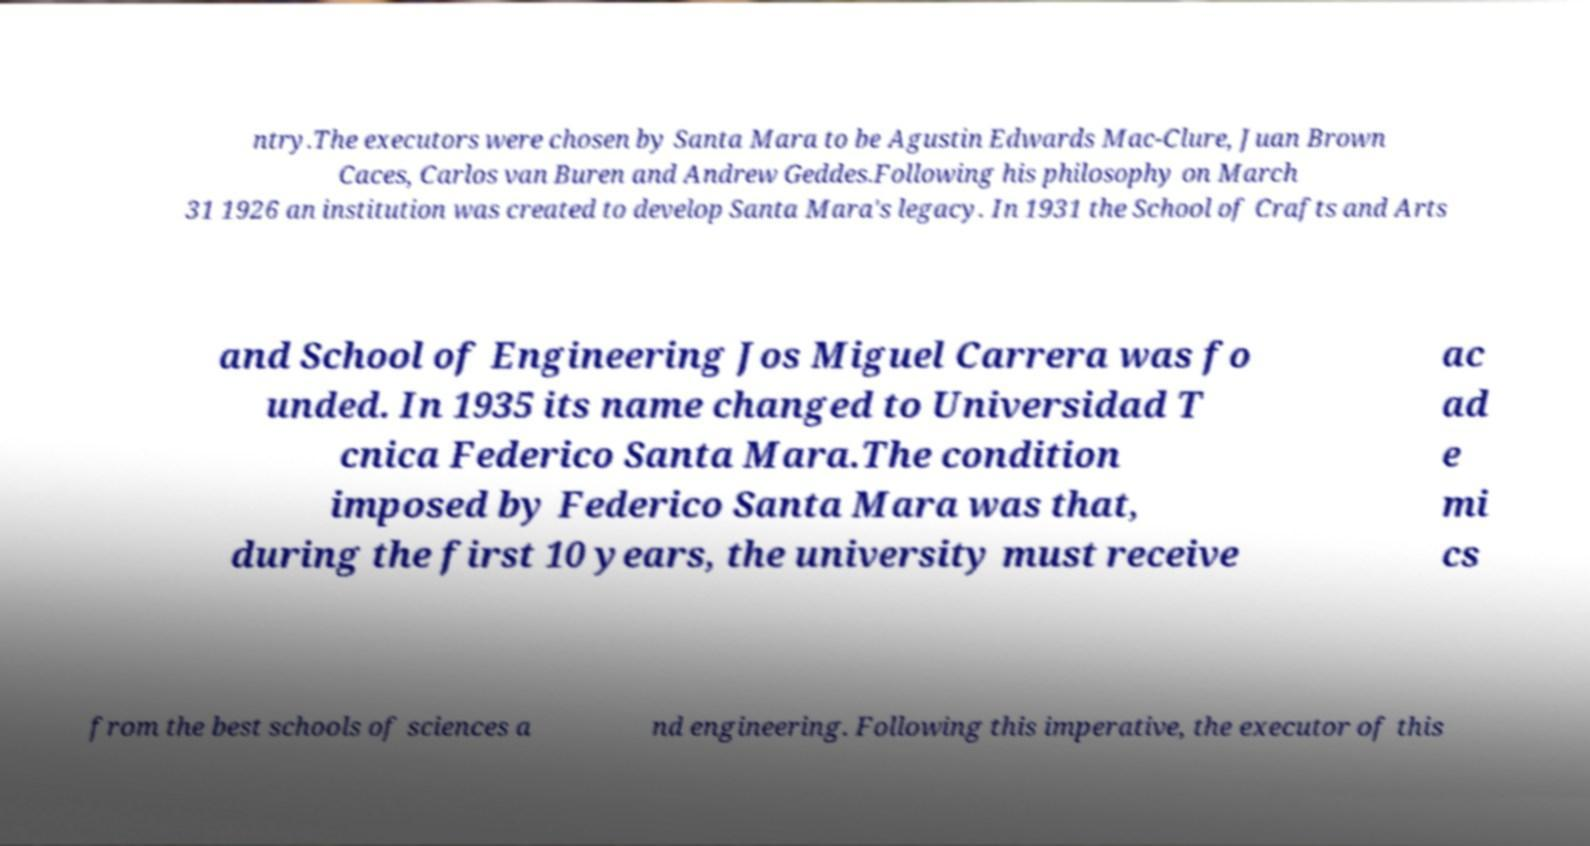For documentation purposes, I need the text within this image transcribed. Could you provide that? ntry.The executors were chosen by Santa Mara to be Agustin Edwards Mac-Clure, Juan Brown Caces, Carlos van Buren and Andrew Geddes.Following his philosophy on March 31 1926 an institution was created to develop Santa Mara's legacy. In 1931 the School of Crafts and Arts and School of Engineering Jos Miguel Carrera was fo unded. In 1935 its name changed to Universidad T cnica Federico Santa Mara.The condition imposed by Federico Santa Mara was that, during the first 10 years, the university must receive ac ad e mi cs from the best schools of sciences a nd engineering. Following this imperative, the executor of this 